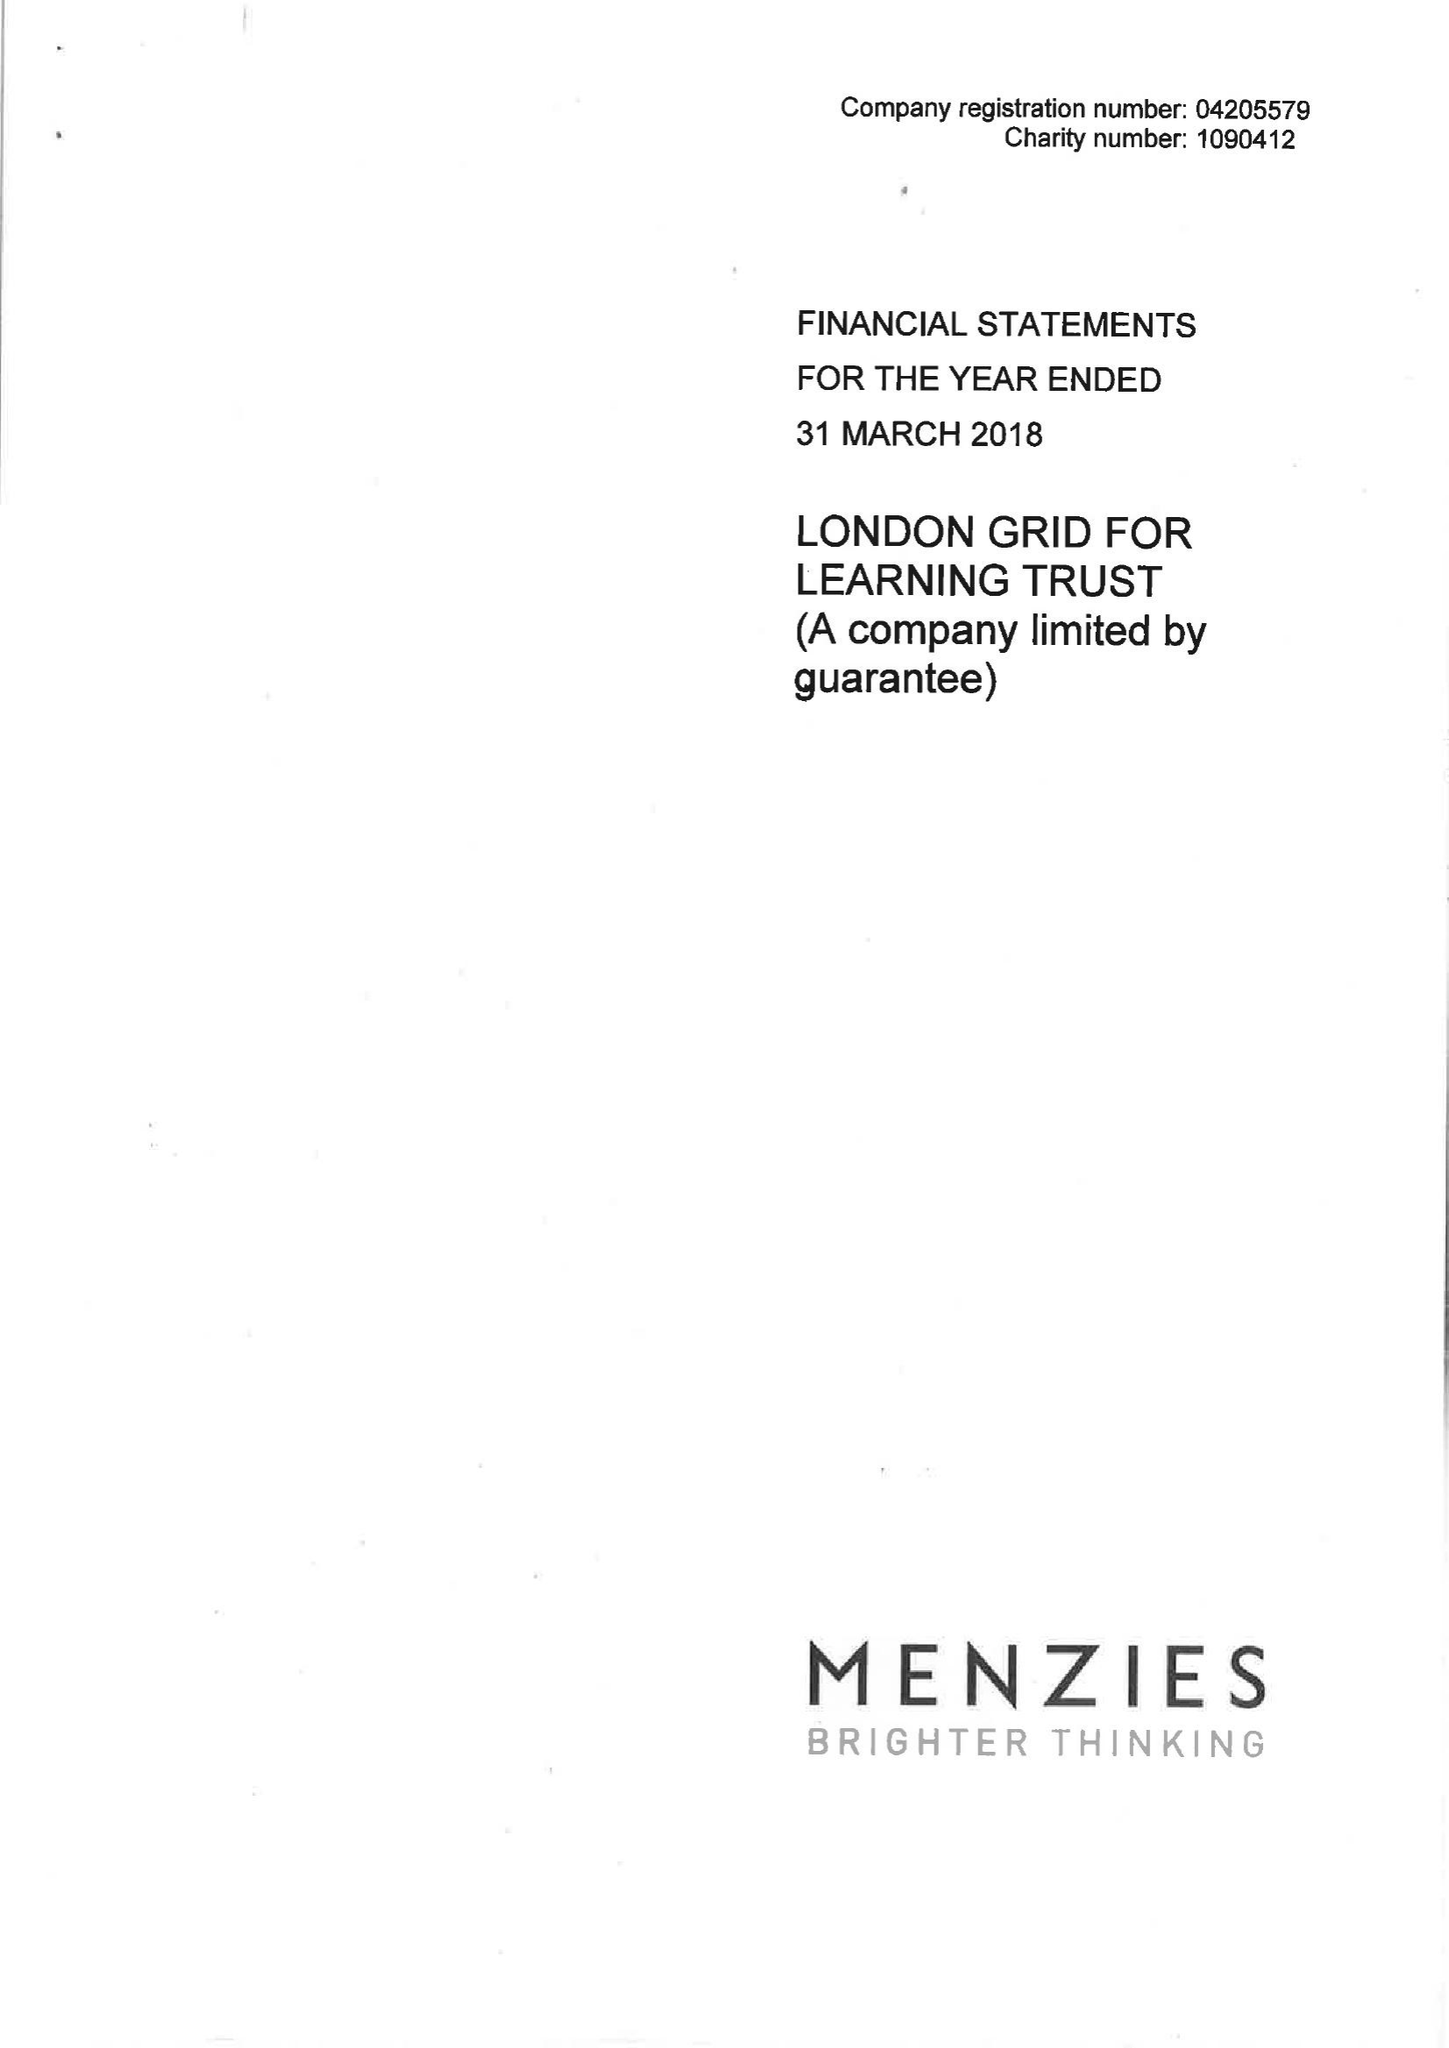What is the value for the address__post_town?
Answer the question using a single word or phrase. LONDON 